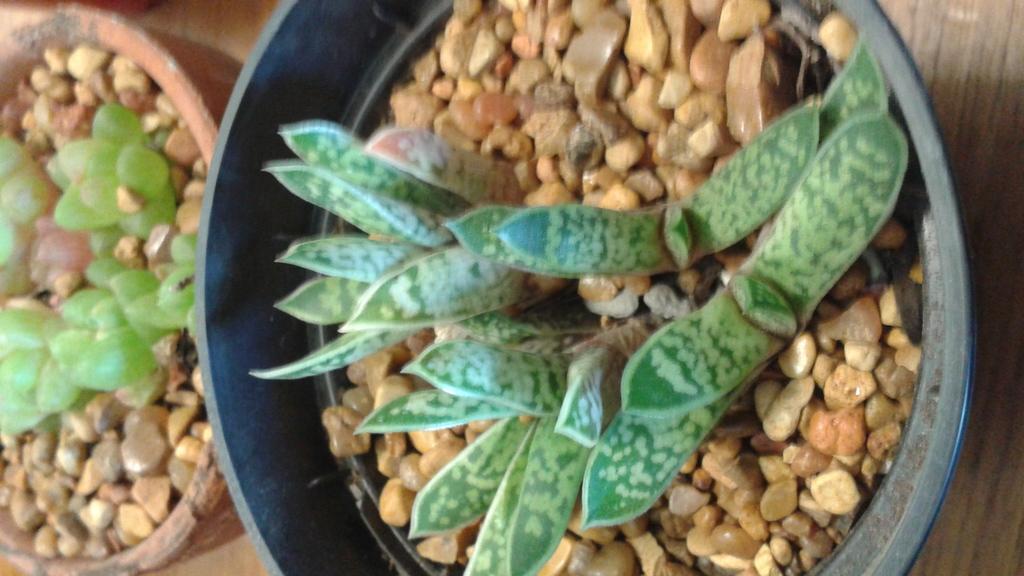Can you describe this image briefly? In this image, I can see two flower pots, in which I can see houseplants and stones kept on the floor. This image taken, maybe in a day. 